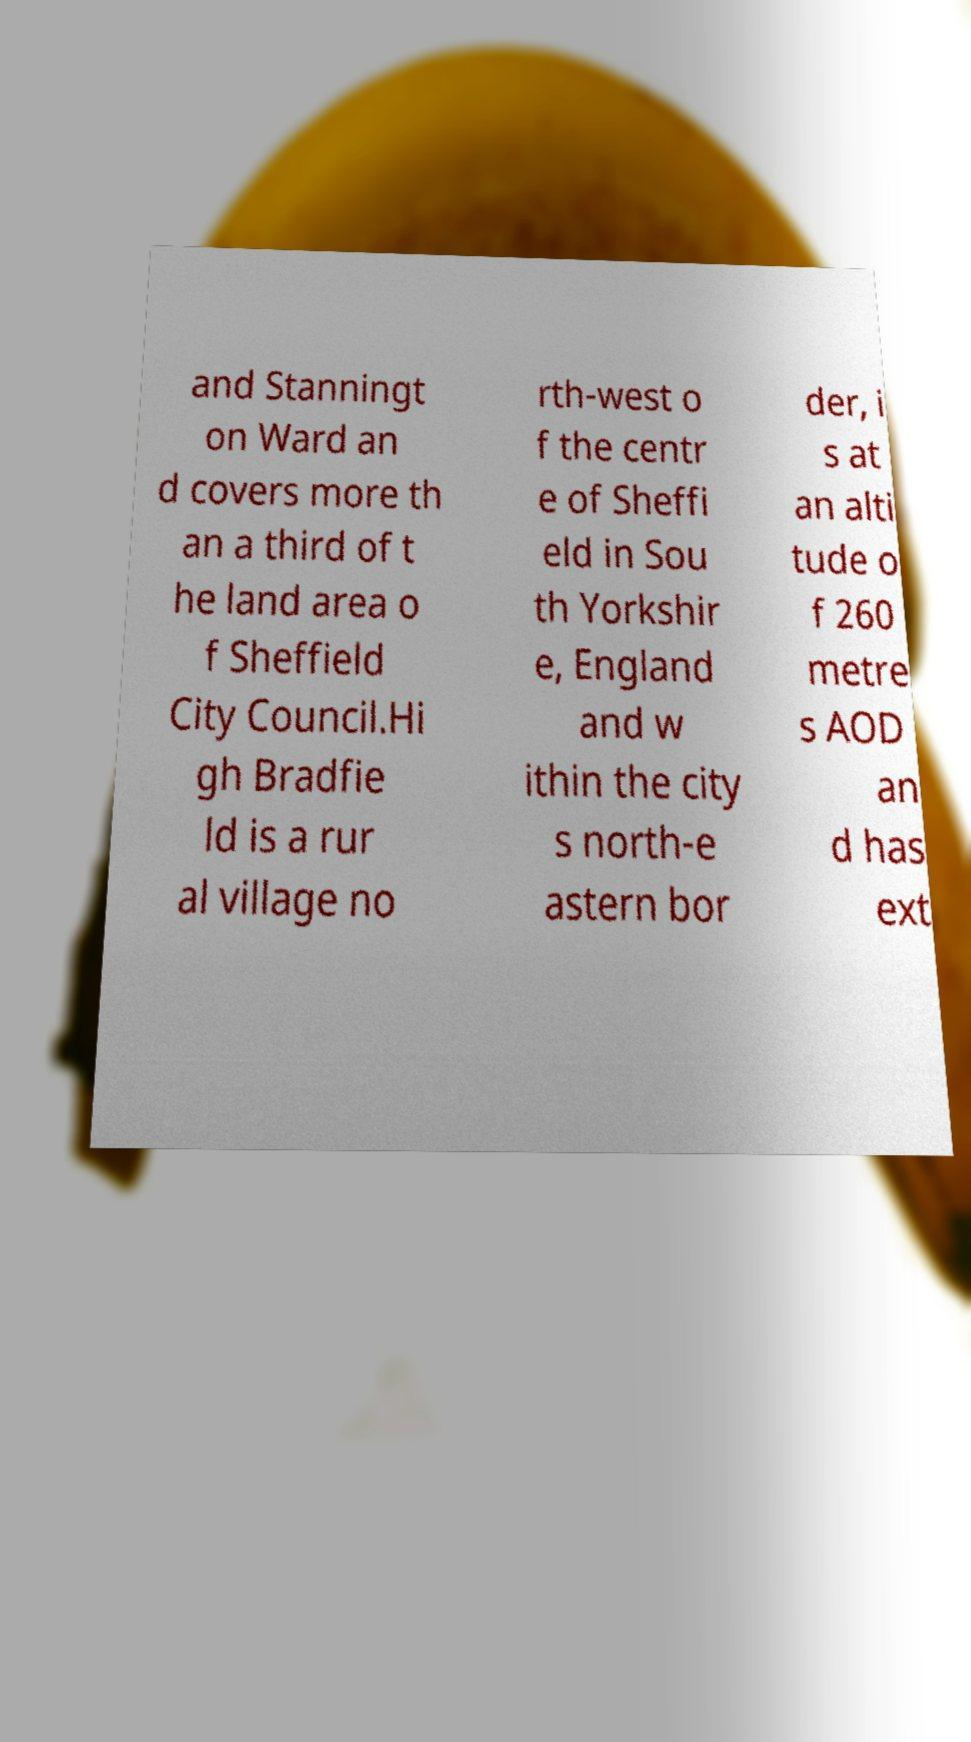Could you extract and type out the text from this image? and Stanningt on Ward an d covers more th an a third of t he land area o f Sheffield City Council.Hi gh Bradfie ld is a rur al village no rth-west o f the centr e of Sheffi eld in Sou th Yorkshir e, England and w ithin the city s north-e astern bor der, i s at an alti tude o f 260 metre s AOD an d has ext 